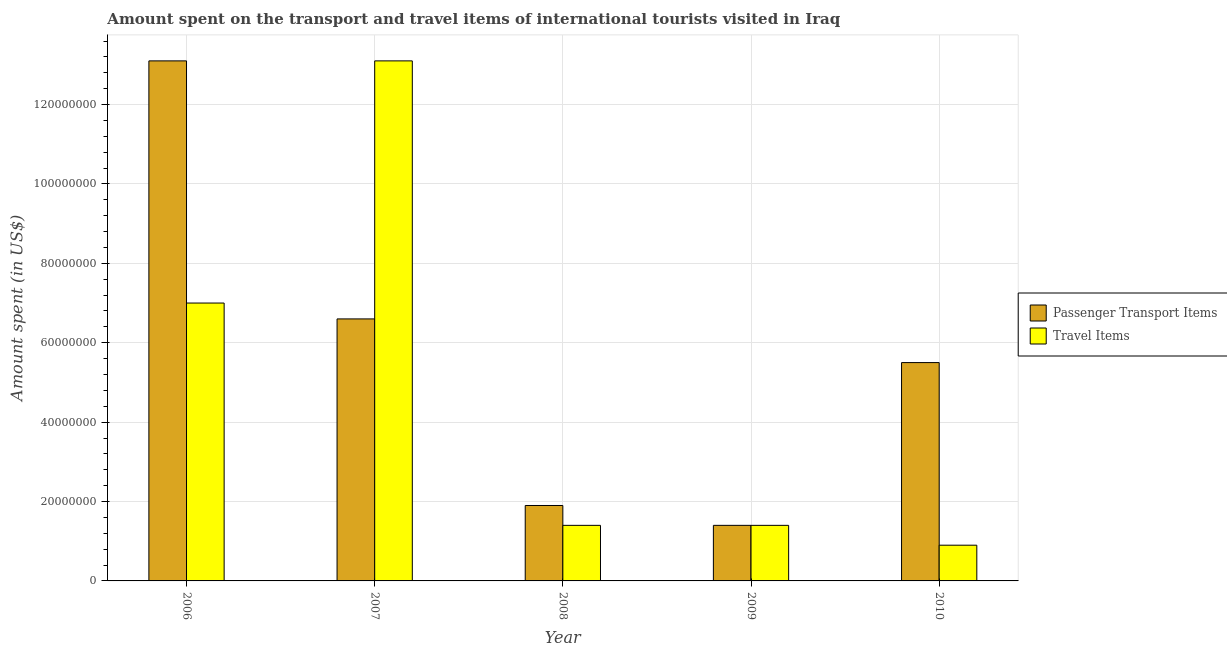How many groups of bars are there?
Make the answer very short. 5. Are the number of bars per tick equal to the number of legend labels?
Your response must be concise. Yes. Are the number of bars on each tick of the X-axis equal?
Offer a terse response. Yes. What is the label of the 3rd group of bars from the left?
Your answer should be compact. 2008. What is the amount spent in travel items in 2009?
Your answer should be very brief. 1.40e+07. Across all years, what is the maximum amount spent on passenger transport items?
Your response must be concise. 1.31e+08. Across all years, what is the minimum amount spent in travel items?
Your response must be concise. 9.00e+06. In which year was the amount spent on passenger transport items minimum?
Provide a short and direct response. 2009. What is the total amount spent on passenger transport items in the graph?
Offer a terse response. 2.85e+08. What is the difference between the amount spent on passenger transport items in 2007 and that in 2008?
Make the answer very short. 4.70e+07. What is the difference between the amount spent in travel items in 2006 and the amount spent on passenger transport items in 2007?
Offer a terse response. -6.10e+07. What is the average amount spent on passenger transport items per year?
Provide a short and direct response. 5.70e+07. In the year 2009, what is the difference between the amount spent on passenger transport items and amount spent in travel items?
Give a very brief answer. 0. In how many years, is the amount spent in travel items greater than 16000000 US$?
Provide a short and direct response. 2. What is the ratio of the amount spent in travel items in 2008 to that in 2009?
Offer a very short reply. 1. Is the amount spent in travel items in 2008 less than that in 2010?
Your answer should be very brief. No. What is the difference between the highest and the second highest amount spent on passenger transport items?
Provide a short and direct response. 6.50e+07. What is the difference between the highest and the lowest amount spent on passenger transport items?
Your answer should be very brief. 1.17e+08. Is the sum of the amount spent in travel items in 2008 and 2010 greater than the maximum amount spent on passenger transport items across all years?
Your answer should be compact. No. What does the 2nd bar from the left in 2009 represents?
Provide a short and direct response. Travel Items. What does the 2nd bar from the right in 2008 represents?
Provide a short and direct response. Passenger Transport Items. Are all the bars in the graph horizontal?
Provide a succinct answer. No. How many years are there in the graph?
Your response must be concise. 5. What is the difference between two consecutive major ticks on the Y-axis?
Offer a terse response. 2.00e+07. Does the graph contain any zero values?
Keep it short and to the point. No. Where does the legend appear in the graph?
Offer a very short reply. Center right. How are the legend labels stacked?
Make the answer very short. Vertical. What is the title of the graph?
Ensure brevity in your answer.  Amount spent on the transport and travel items of international tourists visited in Iraq. Does "Electricity" appear as one of the legend labels in the graph?
Your response must be concise. No. What is the label or title of the Y-axis?
Give a very brief answer. Amount spent (in US$). What is the Amount spent (in US$) in Passenger Transport Items in 2006?
Offer a terse response. 1.31e+08. What is the Amount spent (in US$) in Travel Items in 2006?
Offer a terse response. 7.00e+07. What is the Amount spent (in US$) of Passenger Transport Items in 2007?
Provide a short and direct response. 6.60e+07. What is the Amount spent (in US$) in Travel Items in 2007?
Make the answer very short. 1.31e+08. What is the Amount spent (in US$) of Passenger Transport Items in 2008?
Your answer should be compact. 1.90e+07. What is the Amount spent (in US$) in Travel Items in 2008?
Provide a succinct answer. 1.40e+07. What is the Amount spent (in US$) in Passenger Transport Items in 2009?
Ensure brevity in your answer.  1.40e+07. What is the Amount spent (in US$) in Travel Items in 2009?
Keep it short and to the point. 1.40e+07. What is the Amount spent (in US$) in Passenger Transport Items in 2010?
Your answer should be compact. 5.50e+07. What is the Amount spent (in US$) of Travel Items in 2010?
Your response must be concise. 9.00e+06. Across all years, what is the maximum Amount spent (in US$) in Passenger Transport Items?
Provide a short and direct response. 1.31e+08. Across all years, what is the maximum Amount spent (in US$) in Travel Items?
Provide a short and direct response. 1.31e+08. Across all years, what is the minimum Amount spent (in US$) in Passenger Transport Items?
Provide a succinct answer. 1.40e+07. Across all years, what is the minimum Amount spent (in US$) in Travel Items?
Offer a very short reply. 9.00e+06. What is the total Amount spent (in US$) of Passenger Transport Items in the graph?
Make the answer very short. 2.85e+08. What is the total Amount spent (in US$) of Travel Items in the graph?
Your response must be concise. 2.38e+08. What is the difference between the Amount spent (in US$) of Passenger Transport Items in 2006 and that in 2007?
Your answer should be very brief. 6.50e+07. What is the difference between the Amount spent (in US$) of Travel Items in 2006 and that in 2007?
Your answer should be compact. -6.10e+07. What is the difference between the Amount spent (in US$) of Passenger Transport Items in 2006 and that in 2008?
Keep it short and to the point. 1.12e+08. What is the difference between the Amount spent (in US$) in Travel Items in 2006 and that in 2008?
Keep it short and to the point. 5.60e+07. What is the difference between the Amount spent (in US$) of Passenger Transport Items in 2006 and that in 2009?
Your answer should be very brief. 1.17e+08. What is the difference between the Amount spent (in US$) in Travel Items in 2006 and that in 2009?
Keep it short and to the point. 5.60e+07. What is the difference between the Amount spent (in US$) in Passenger Transport Items in 2006 and that in 2010?
Your response must be concise. 7.60e+07. What is the difference between the Amount spent (in US$) of Travel Items in 2006 and that in 2010?
Keep it short and to the point. 6.10e+07. What is the difference between the Amount spent (in US$) in Passenger Transport Items in 2007 and that in 2008?
Provide a succinct answer. 4.70e+07. What is the difference between the Amount spent (in US$) of Travel Items in 2007 and that in 2008?
Ensure brevity in your answer.  1.17e+08. What is the difference between the Amount spent (in US$) of Passenger Transport Items in 2007 and that in 2009?
Give a very brief answer. 5.20e+07. What is the difference between the Amount spent (in US$) in Travel Items in 2007 and that in 2009?
Offer a terse response. 1.17e+08. What is the difference between the Amount spent (in US$) of Passenger Transport Items in 2007 and that in 2010?
Your response must be concise. 1.10e+07. What is the difference between the Amount spent (in US$) of Travel Items in 2007 and that in 2010?
Your answer should be very brief. 1.22e+08. What is the difference between the Amount spent (in US$) of Travel Items in 2008 and that in 2009?
Ensure brevity in your answer.  0. What is the difference between the Amount spent (in US$) in Passenger Transport Items in 2008 and that in 2010?
Your answer should be compact. -3.60e+07. What is the difference between the Amount spent (in US$) in Passenger Transport Items in 2009 and that in 2010?
Provide a succinct answer. -4.10e+07. What is the difference between the Amount spent (in US$) in Travel Items in 2009 and that in 2010?
Make the answer very short. 5.00e+06. What is the difference between the Amount spent (in US$) in Passenger Transport Items in 2006 and the Amount spent (in US$) in Travel Items in 2008?
Provide a short and direct response. 1.17e+08. What is the difference between the Amount spent (in US$) of Passenger Transport Items in 2006 and the Amount spent (in US$) of Travel Items in 2009?
Your answer should be very brief. 1.17e+08. What is the difference between the Amount spent (in US$) of Passenger Transport Items in 2006 and the Amount spent (in US$) of Travel Items in 2010?
Ensure brevity in your answer.  1.22e+08. What is the difference between the Amount spent (in US$) in Passenger Transport Items in 2007 and the Amount spent (in US$) in Travel Items in 2008?
Offer a terse response. 5.20e+07. What is the difference between the Amount spent (in US$) in Passenger Transport Items in 2007 and the Amount spent (in US$) in Travel Items in 2009?
Give a very brief answer. 5.20e+07. What is the difference between the Amount spent (in US$) of Passenger Transport Items in 2007 and the Amount spent (in US$) of Travel Items in 2010?
Give a very brief answer. 5.70e+07. What is the difference between the Amount spent (in US$) in Passenger Transport Items in 2008 and the Amount spent (in US$) in Travel Items in 2009?
Give a very brief answer. 5.00e+06. What is the average Amount spent (in US$) in Passenger Transport Items per year?
Ensure brevity in your answer.  5.70e+07. What is the average Amount spent (in US$) in Travel Items per year?
Offer a terse response. 4.76e+07. In the year 2006, what is the difference between the Amount spent (in US$) of Passenger Transport Items and Amount spent (in US$) of Travel Items?
Provide a short and direct response. 6.10e+07. In the year 2007, what is the difference between the Amount spent (in US$) in Passenger Transport Items and Amount spent (in US$) in Travel Items?
Provide a short and direct response. -6.50e+07. In the year 2009, what is the difference between the Amount spent (in US$) of Passenger Transport Items and Amount spent (in US$) of Travel Items?
Your answer should be compact. 0. In the year 2010, what is the difference between the Amount spent (in US$) of Passenger Transport Items and Amount spent (in US$) of Travel Items?
Give a very brief answer. 4.60e+07. What is the ratio of the Amount spent (in US$) in Passenger Transport Items in 2006 to that in 2007?
Provide a succinct answer. 1.98. What is the ratio of the Amount spent (in US$) of Travel Items in 2006 to that in 2007?
Ensure brevity in your answer.  0.53. What is the ratio of the Amount spent (in US$) in Passenger Transport Items in 2006 to that in 2008?
Keep it short and to the point. 6.89. What is the ratio of the Amount spent (in US$) in Passenger Transport Items in 2006 to that in 2009?
Make the answer very short. 9.36. What is the ratio of the Amount spent (in US$) of Passenger Transport Items in 2006 to that in 2010?
Ensure brevity in your answer.  2.38. What is the ratio of the Amount spent (in US$) of Travel Items in 2006 to that in 2010?
Your answer should be very brief. 7.78. What is the ratio of the Amount spent (in US$) in Passenger Transport Items in 2007 to that in 2008?
Offer a very short reply. 3.47. What is the ratio of the Amount spent (in US$) in Travel Items in 2007 to that in 2008?
Your answer should be very brief. 9.36. What is the ratio of the Amount spent (in US$) of Passenger Transport Items in 2007 to that in 2009?
Provide a succinct answer. 4.71. What is the ratio of the Amount spent (in US$) in Travel Items in 2007 to that in 2009?
Your answer should be very brief. 9.36. What is the ratio of the Amount spent (in US$) in Travel Items in 2007 to that in 2010?
Ensure brevity in your answer.  14.56. What is the ratio of the Amount spent (in US$) of Passenger Transport Items in 2008 to that in 2009?
Provide a short and direct response. 1.36. What is the ratio of the Amount spent (in US$) of Travel Items in 2008 to that in 2009?
Ensure brevity in your answer.  1. What is the ratio of the Amount spent (in US$) of Passenger Transport Items in 2008 to that in 2010?
Keep it short and to the point. 0.35. What is the ratio of the Amount spent (in US$) of Travel Items in 2008 to that in 2010?
Provide a succinct answer. 1.56. What is the ratio of the Amount spent (in US$) of Passenger Transport Items in 2009 to that in 2010?
Give a very brief answer. 0.25. What is the ratio of the Amount spent (in US$) of Travel Items in 2009 to that in 2010?
Your answer should be very brief. 1.56. What is the difference between the highest and the second highest Amount spent (in US$) of Passenger Transport Items?
Offer a terse response. 6.50e+07. What is the difference between the highest and the second highest Amount spent (in US$) in Travel Items?
Ensure brevity in your answer.  6.10e+07. What is the difference between the highest and the lowest Amount spent (in US$) in Passenger Transport Items?
Your answer should be compact. 1.17e+08. What is the difference between the highest and the lowest Amount spent (in US$) in Travel Items?
Offer a terse response. 1.22e+08. 